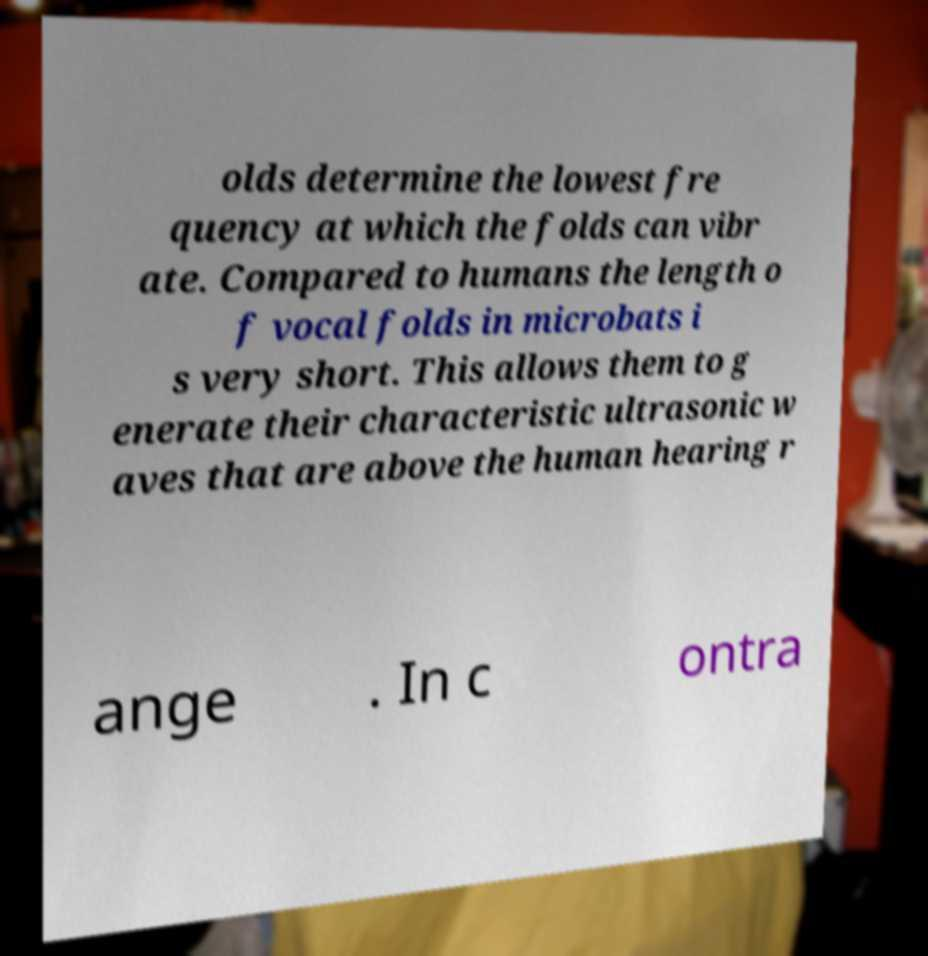What messages or text are displayed in this image? I need them in a readable, typed format. olds determine the lowest fre quency at which the folds can vibr ate. Compared to humans the length o f vocal folds in microbats i s very short. This allows them to g enerate their characteristic ultrasonic w aves that are above the human hearing r ange . In c ontra 